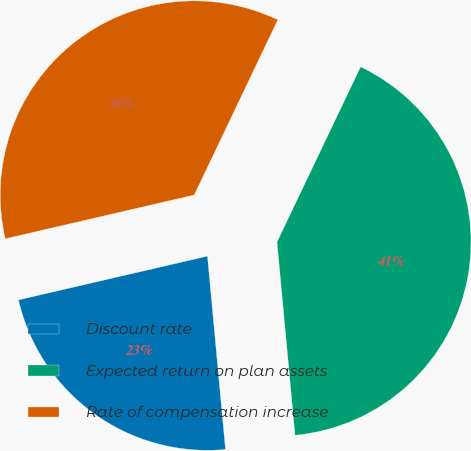Convert chart to OTSL. <chart><loc_0><loc_0><loc_500><loc_500><pie_chart><fcel>Discount rate<fcel>Expected return on plan assets<fcel>Rate of compensation increase<nl><fcel>22.86%<fcel>41.43%<fcel>35.71%<nl></chart> 